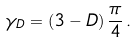Convert formula to latex. <formula><loc_0><loc_0><loc_500><loc_500>\gamma _ { D } = \left ( 3 - D \right ) \frac { \pi } { 4 } \, .</formula> 